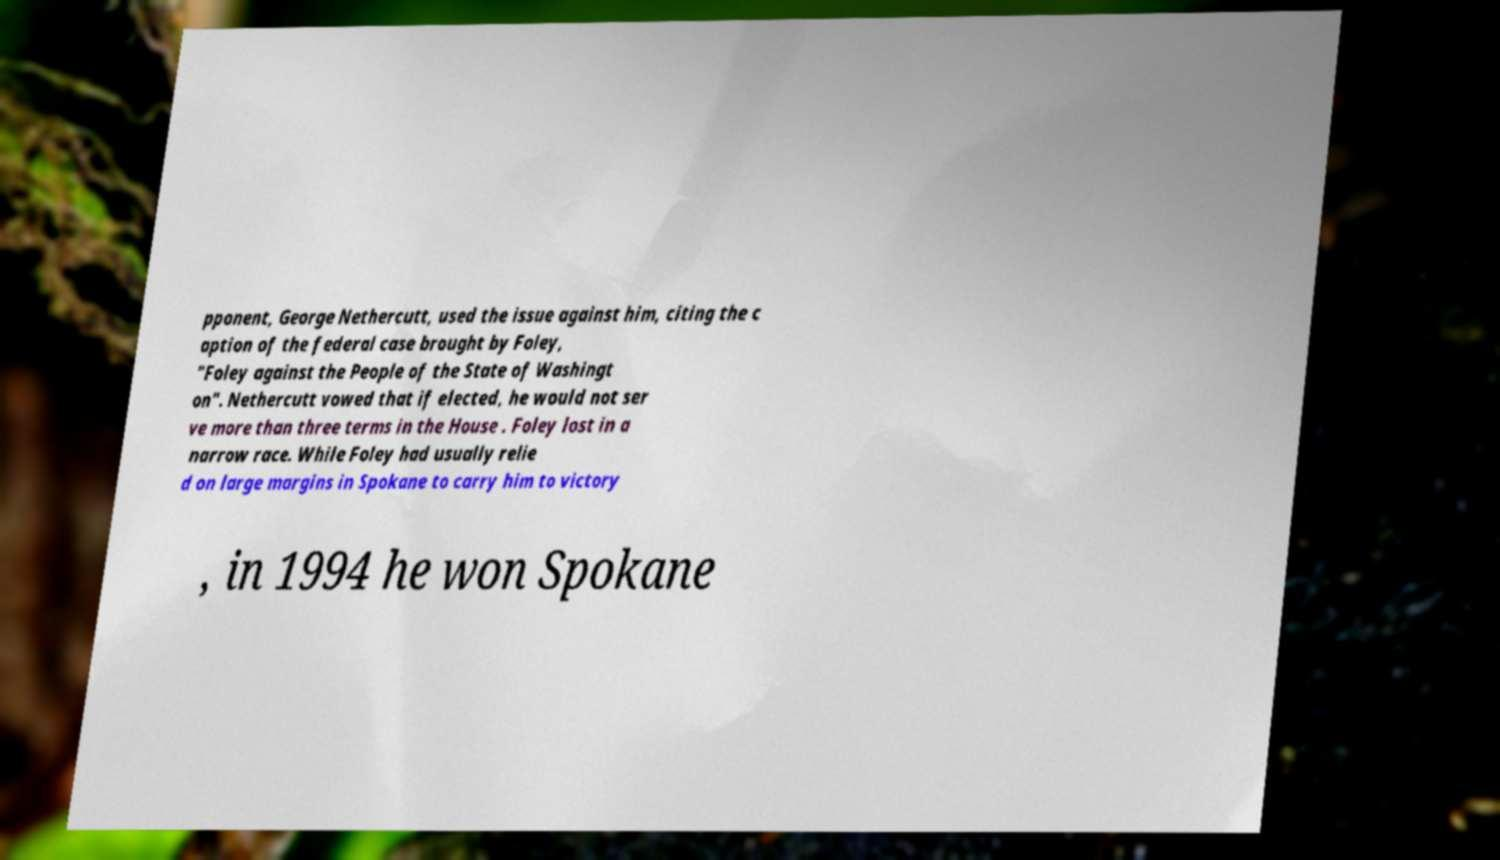I need the written content from this picture converted into text. Can you do that? pponent, George Nethercutt, used the issue against him, citing the c aption of the federal case brought by Foley, "Foley against the People of the State of Washingt on". Nethercutt vowed that if elected, he would not ser ve more than three terms in the House . Foley lost in a narrow race. While Foley had usually relie d on large margins in Spokane to carry him to victory , in 1994 he won Spokane 